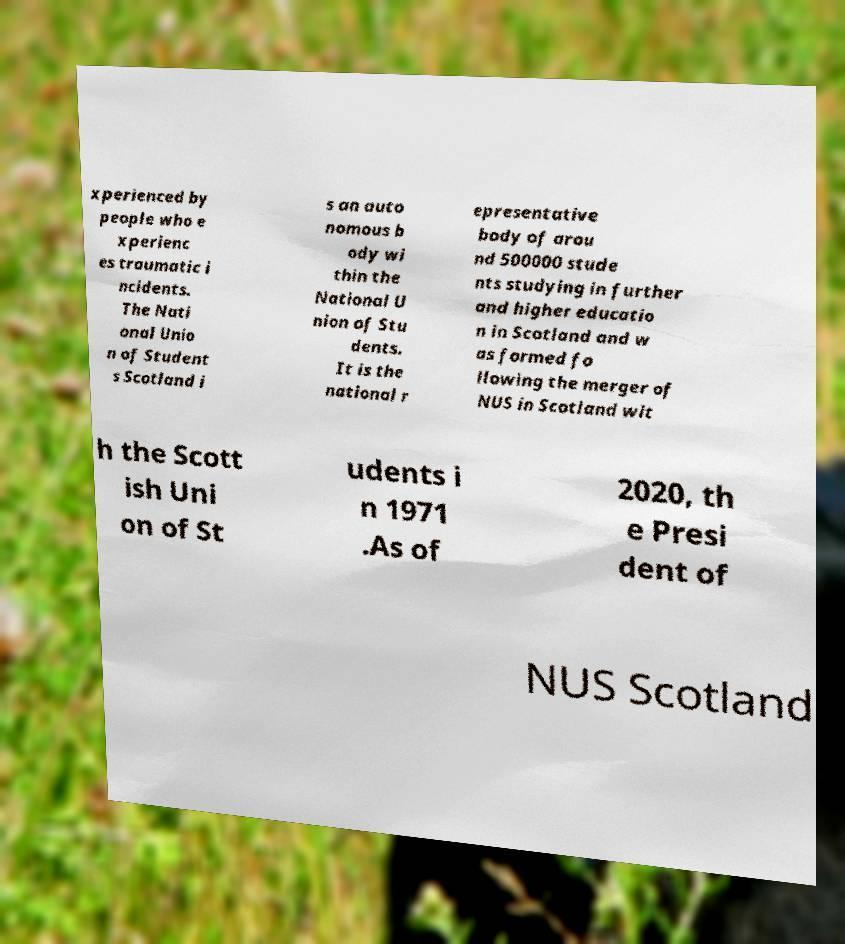Can you accurately transcribe the text from the provided image for me? xperienced by people who e xperienc es traumatic i ncidents. The Nati onal Unio n of Student s Scotland i s an auto nomous b ody wi thin the National U nion of Stu dents. It is the national r epresentative body of arou nd 500000 stude nts studying in further and higher educatio n in Scotland and w as formed fo llowing the merger of NUS in Scotland wit h the Scott ish Uni on of St udents i n 1971 .As of 2020, th e Presi dent of NUS Scotland 